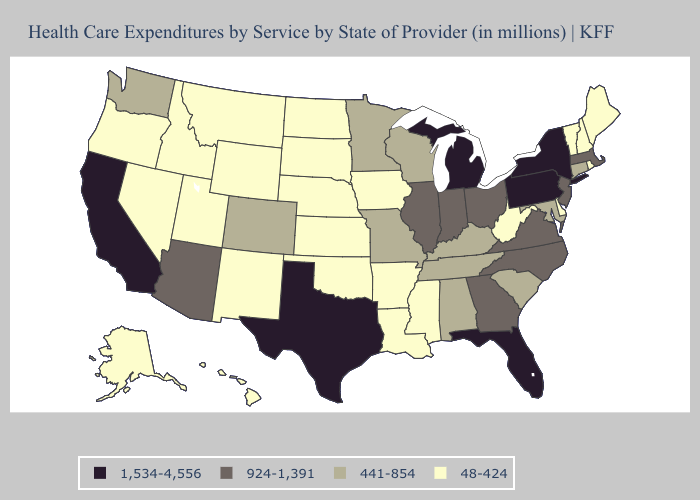What is the highest value in the USA?
Quick response, please. 1,534-4,556. Does New York have the lowest value in the Northeast?
Concise answer only. No. Name the states that have a value in the range 441-854?
Answer briefly. Alabama, Colorado, Connecticut, Kentucky, Maryland, Minnesota, Missouri, South Carolina, Tennessee, Washington, Wisconsin. What is the value of Arizona?
Write a very short answer. 924-1,391. Name the states that have a value in the range 1,534-4,556?
Quick response, please. California, Florida, Michigan, New York, Pennsylvania, Texas. Among the states that border Indiana , which have the highest value?
Short answer required. Michigan. Name the states that have a value in the range 924-1,391?
Keep it brief. Arizona, Georgia, Illinois, Indiana, Massachusetts, New Jersey, North Carolina, Ohio, Virginia. What is the value of Oregon?
Be succinct. 48-424. What is the lowest value in states that border Illinois?
Answer briefly. 48-424. Does the map have missing data?
Answer briefly. No. Does California have a higher value than Pennsylvania?
Answer briefly. No. What is the value of Hawaii?
Short answer required. 48-424. Does Minnesota have the lowest value in the MidWest?
Keep it brief. No. What is the value of California?
Write a very short answer. 1,534-4,556. 